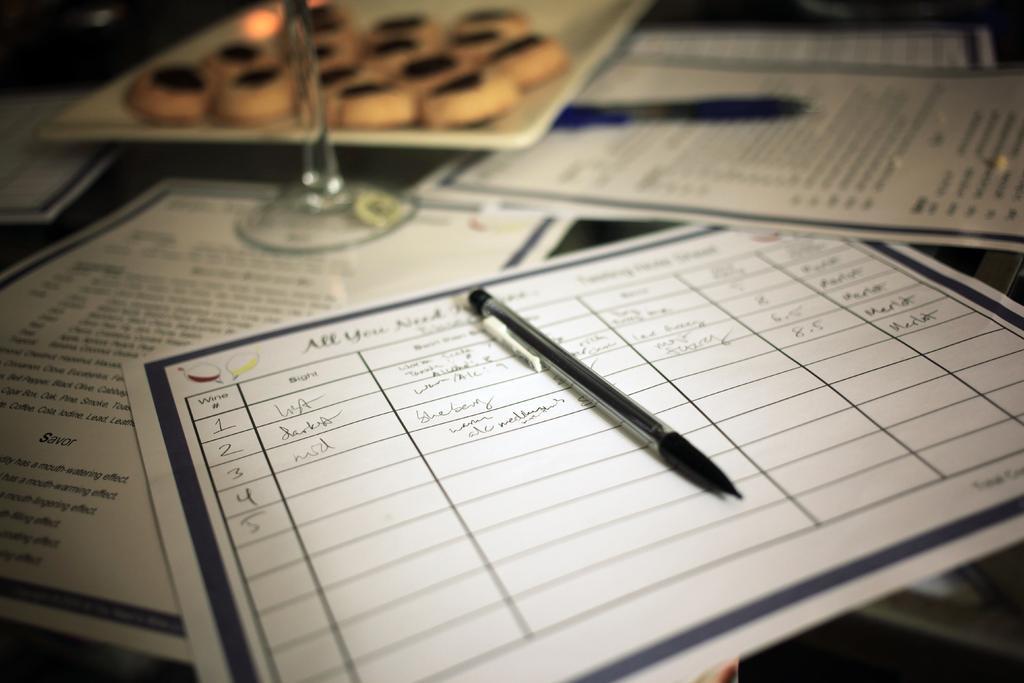Could you give a brief overview of what you see in this image? In this picture I can see some papers, pen, glass are placed on the table. 